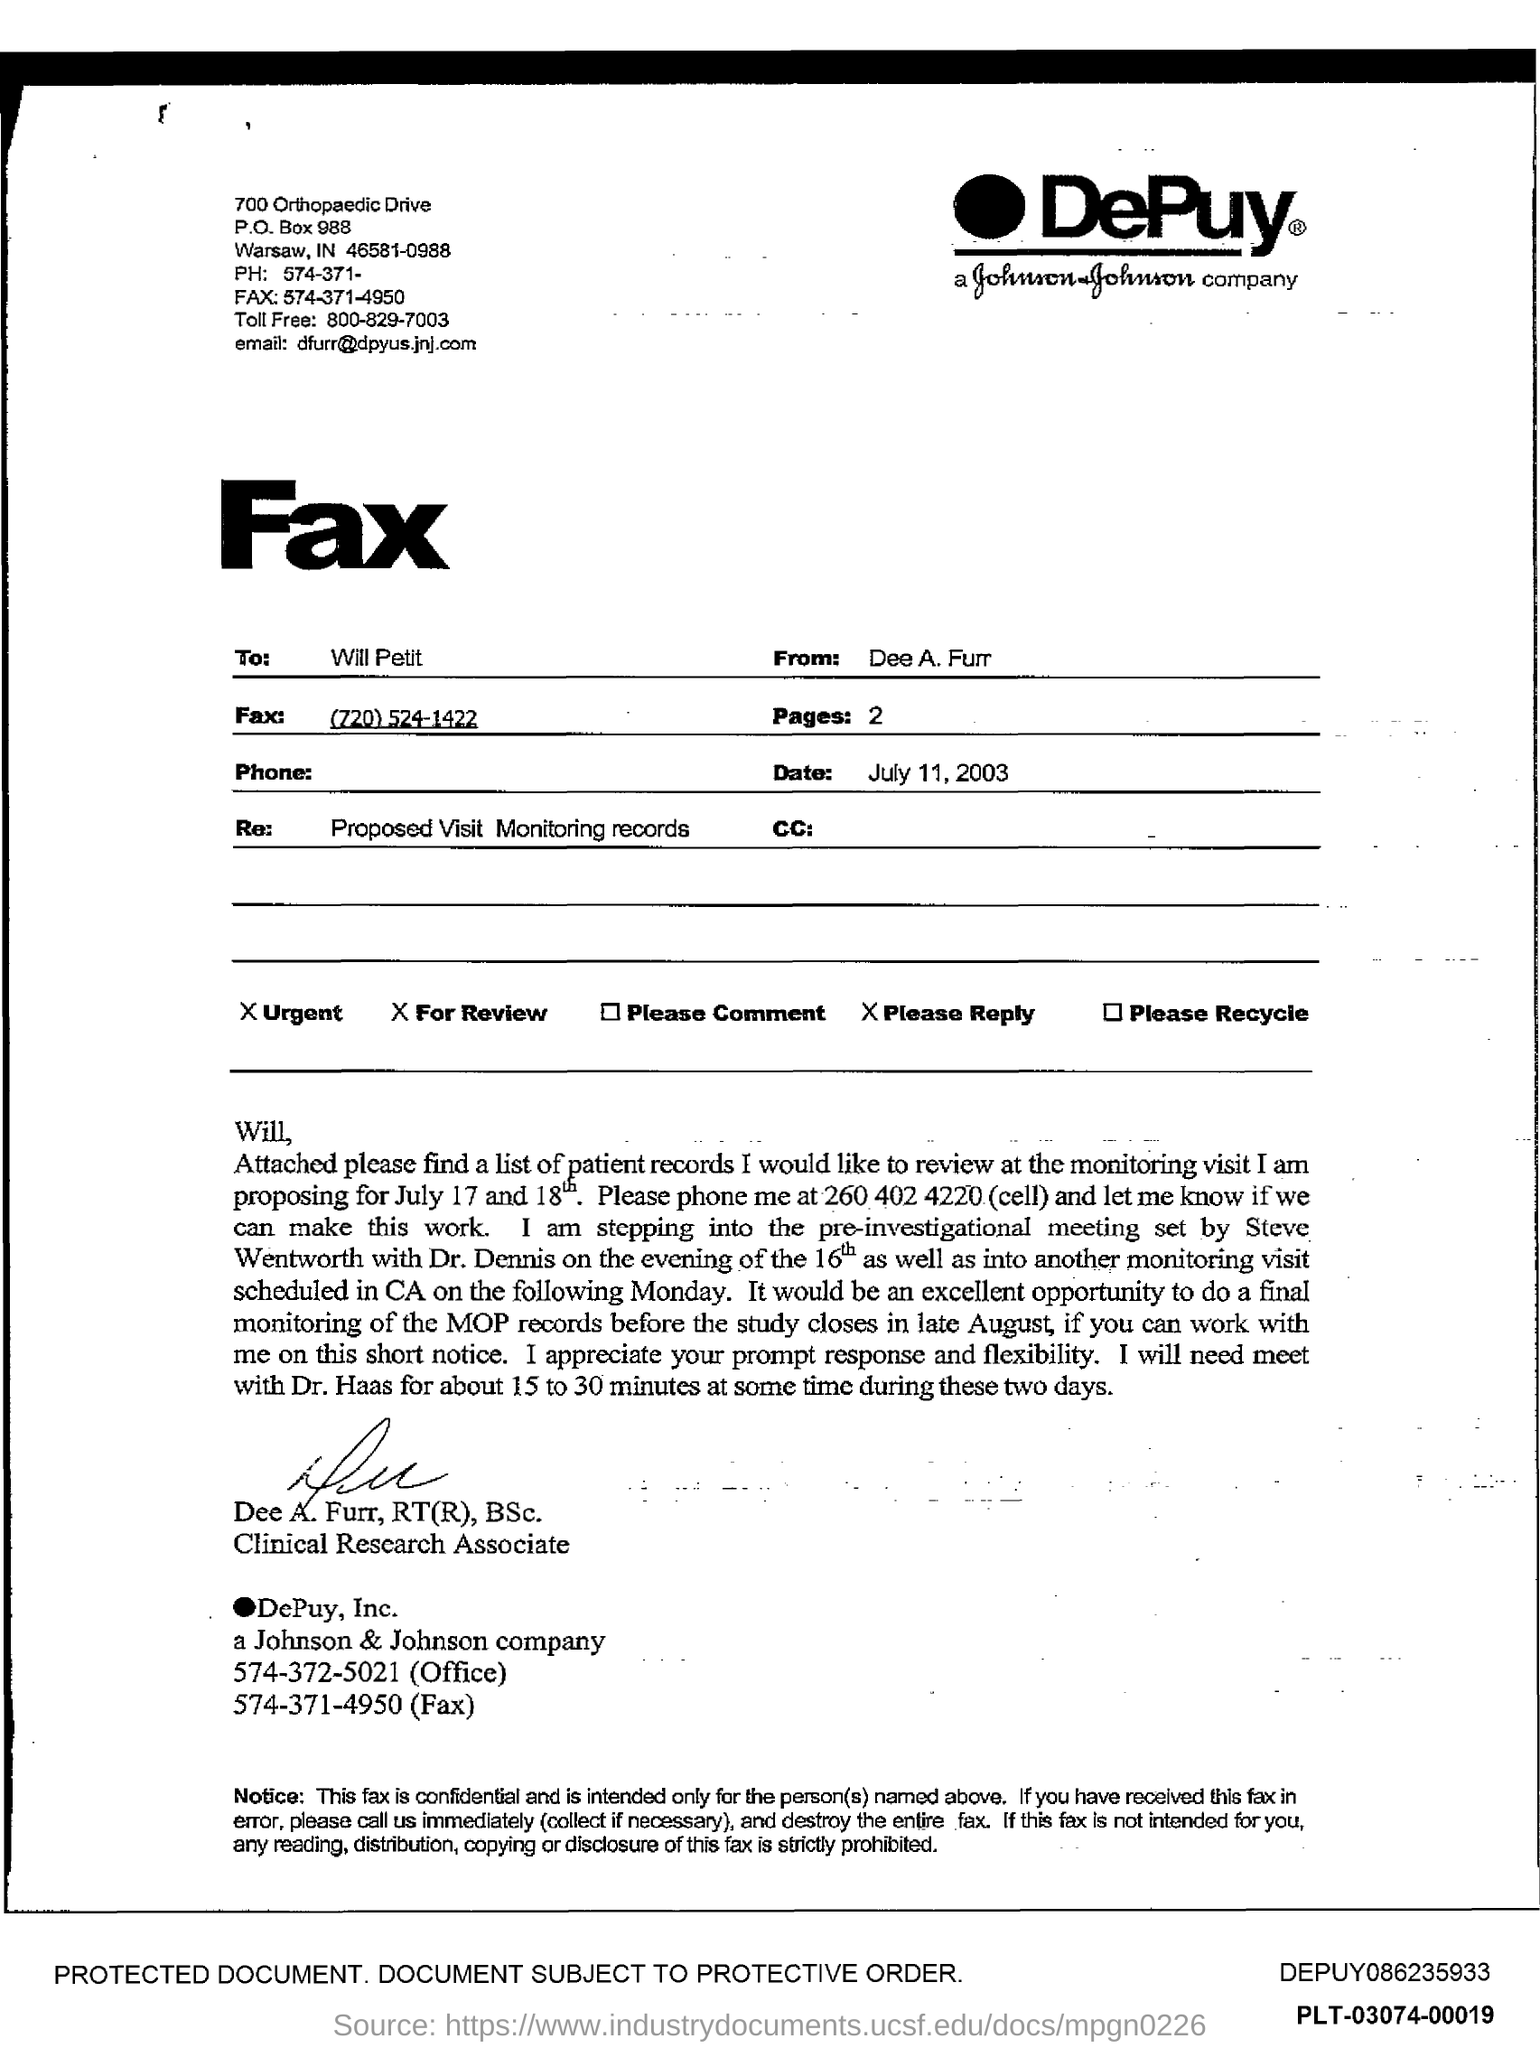List a handful of essential elements in this visual. The PO Box number mentioned in the document is 988. I would like to know the toll free number, which is 800-829-7003. The email address is [dfurr@dpyus.jnj.com](mailto:dfurr@dpyus.jnj.com). 